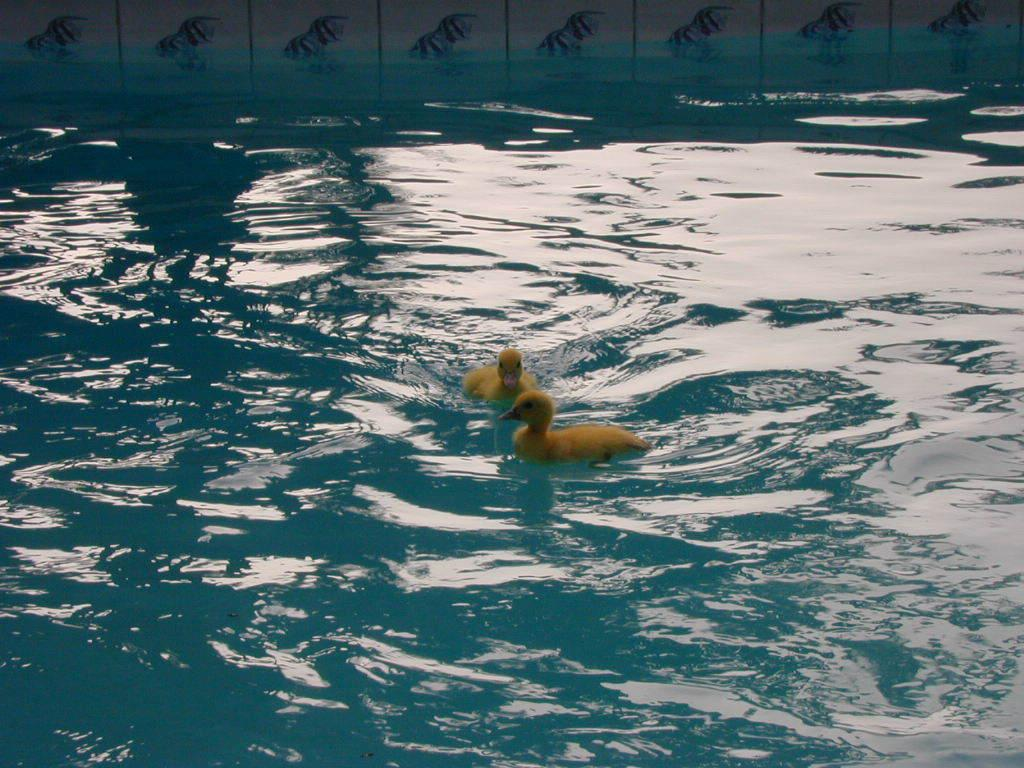How many ducks are in the image? There are two ducks in the image. What color are the ducks? The ducks are in yellow color. What is visible at the bottom of the image? There is water visible at the bottom of the image. What language are the ducks speaking in the image? Ducks do not speak human languages, so it is not possible to determine what language they might be speaking in the image. 